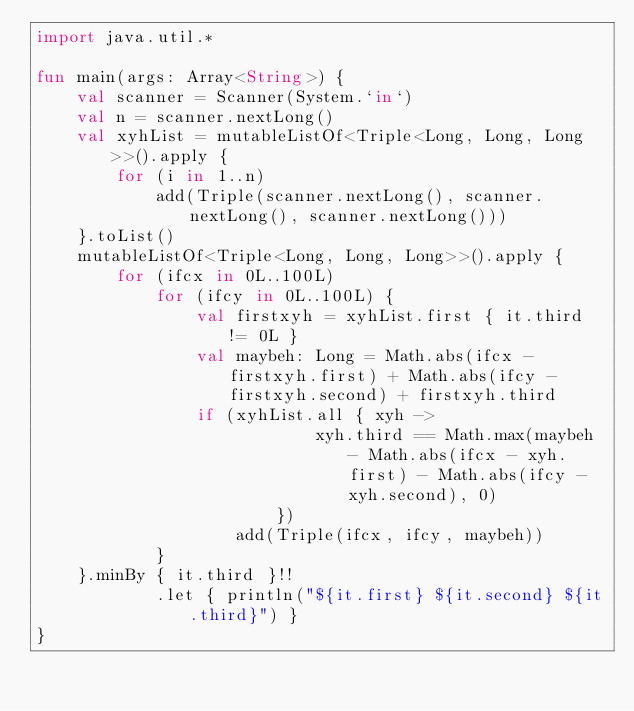<code> <loc_0><loc_0><loc_500><loc_500><_Kotlin_>import java.util.*

fun main(args: Array<String>) {
	val scanner = Scanner(System.`in`)
	val n = scanner.nextLong()
	val xyhList = mutableListOf<Triple<Long, Long, Long>>().apply {
		for (i in 1..n)
			add(Triple(scanner.nextLong(), scanner.nextLong(), scanner.nextLong()))
	}.toList()
	mutableListOf<Triple<Long, Long, Long>>().apply {
		for (ifcx in 0L..100L)
			for (ifcy in 0L..100L) {
				val firstxyh = xyhList.first { it.third != 0L }
				val maybeh: Long = Math.abs(ifcx - firstxyh.first) + Math.abs(ifcy - firstxyh.second) + firstxyh.third
				if (xyhList.all { xyh ->
							xyh.third == Math.max(maybeh - Math.abs(ifcx - xyh.first) - Math.abs(ifcy - xyh.second), 0)
						})
					add(Triple(ifcx, ifcy, maybeh))
			}
	}.minBy { it.third }!!
			.let { println("${it.first} ${it.second} ${it.third}") }
}</code> 